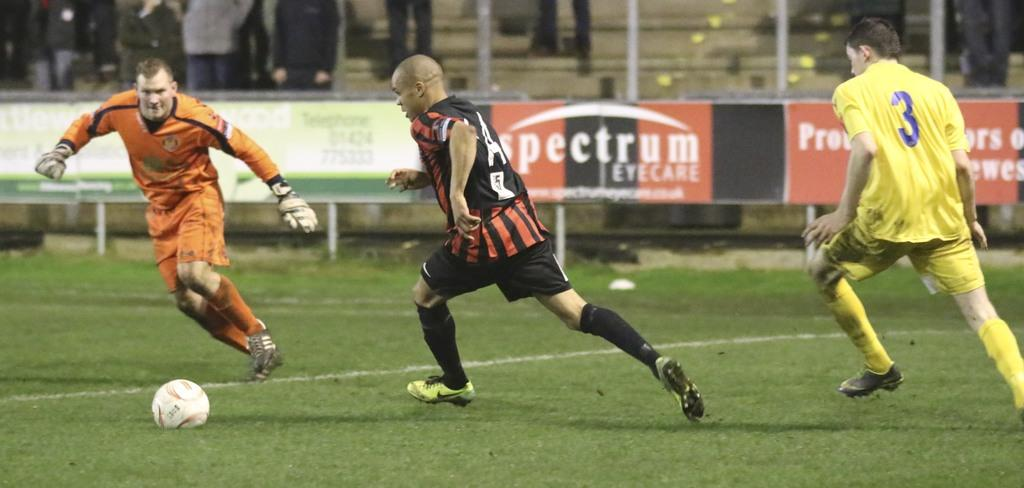Provide a one-sentence caption for the provided image. some soccer players, one with the number 3 on. 